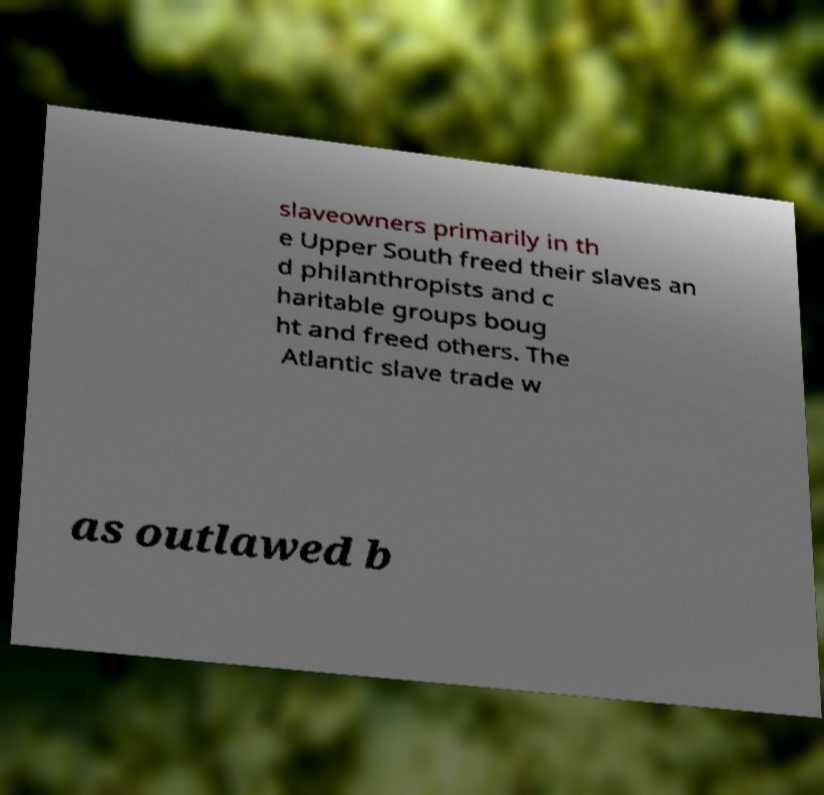Please read and relay the text visible in this image. What does it say? slaveowners primarily in th e Upper South freed their slaves an d philanthropists and c haritable groups boug ht and freed others. The Atlantic slave trade w as outlawed b 